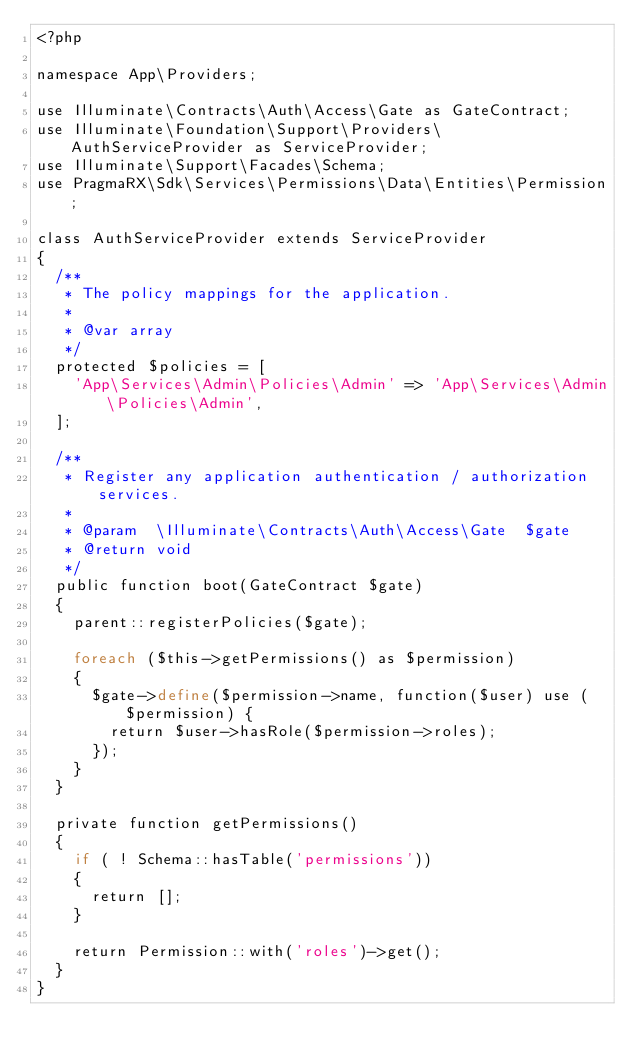<code> <loc_0><loc_0><loc_500><loc_500><_PHP_><?php

namespace App\Providers;

use Illuminate\Contracts\Auth\Access\Gate as GateContract;
use Illuminate\Foundation\Support\Providers\AuthServiceProvider as ServiceProvider;
use Illuminate\Support\Facades\Schema;
use PragmaRX\Sdk\Services\Permissions\Data\Entities\Permission;

class AuthServiceProvider extends ServiceProvider
{
	/**
	 * The policy mappings for the application.
	 *
	 * @var array
	 */
	protected $policies = [
		'App\Services\Admin\Policies\Admin' => 'App\Services\Admin\Policies\Admin',
	];

	/**
	 * Register any application authentication / authorization services.
	 *
	 * @param  \Illuminate\Contracts\Auth\Access\Gate  $gate
	 * @return void
	 */
	public function boot(GateContract $gate)
	{
		parent::registerPolicies($gate);

		foreach ($this->getPermissions() as $permission)
		{
			$gate->define($permission->name, function($user) use ($permission) {
				return $user->hasRole($permission->roles);
			});
		}
	}

	private function getPermissions()
	{
		if ( ! Schema::hasTable('permissions'))
		{
			return [];
		}

		return Permission::with('roles')->get();
	}
}
</code> 